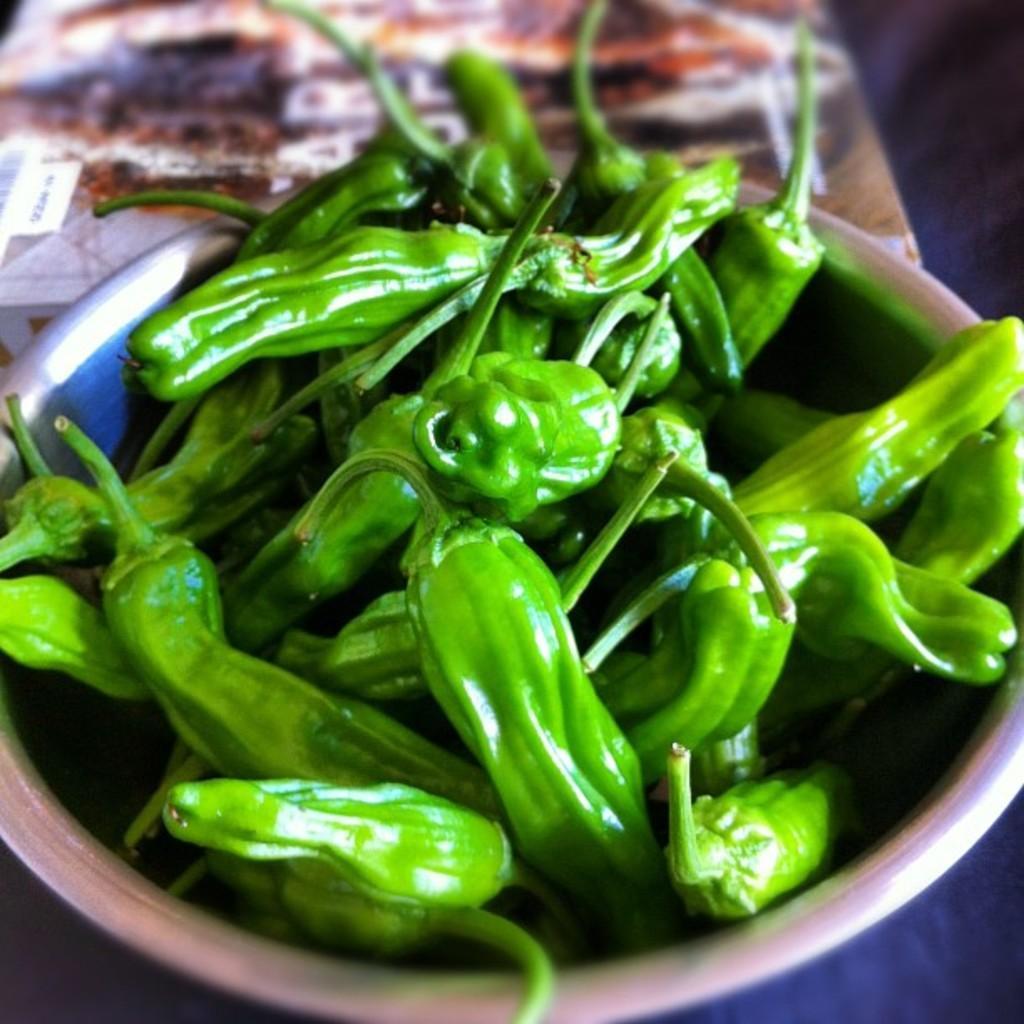Can you describe this image briefly? In the picture I can see green vegetables in a bowl. The background of the image is blurred. 